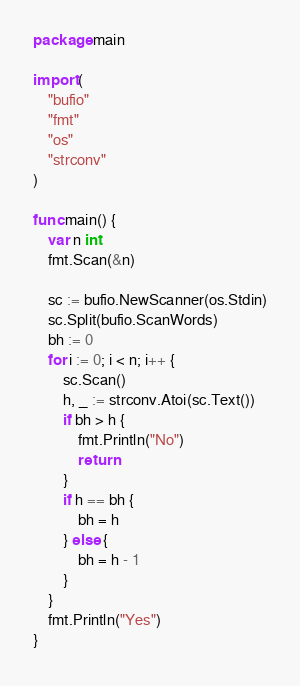Convert code to text. <code><loc_0><loc_0><loc_500><loc_500><_Go_>package main

import (
	"bufio"
	"fmt"
	"os"
	"strconv"
)

func main() {
	var n int
	fmt.Scan(&n)

	sc := bufio.NewScanner(os.Stdin)
	sc.Split(bufio.ScanWords)
	bh := 0
	for i := 0; i < n; i++ {
		sc.Scan()
		h, _ := strconv.Atoi(sc.Text())
		if bh > h {
			fmt.Println("No")
			return
		}
		if h == bh {
			bh = h
		} else {
			bh = h - 1
		}
	}
	fmt.Println("Yes")
}
</code> 